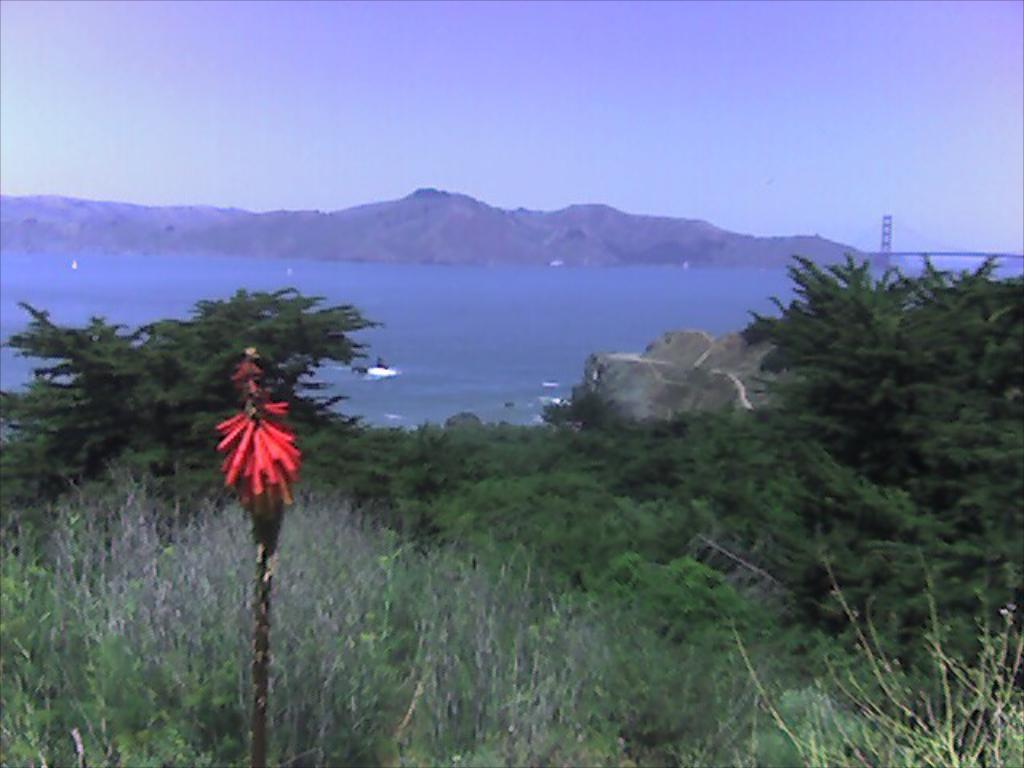What type of natural elements can be seen in the image? There are trees, water, and mountains in the image. What man-made structure is present in the image? There is a bridge in the image. Can you describe any other objects in the image? There is a rock in the image, and there is a red and black color object in the image. What is the color of the sky in the image? The sky is blue and white in color. Can you see any oranges growing on the trees in the image? There are no oranges visible in the image; the trees are not specifically identified as fruit-bearing trees. Is there a window in the image? There is no window present in the image; it features an outdoor landscape with natural elements and a man-made bridge. 